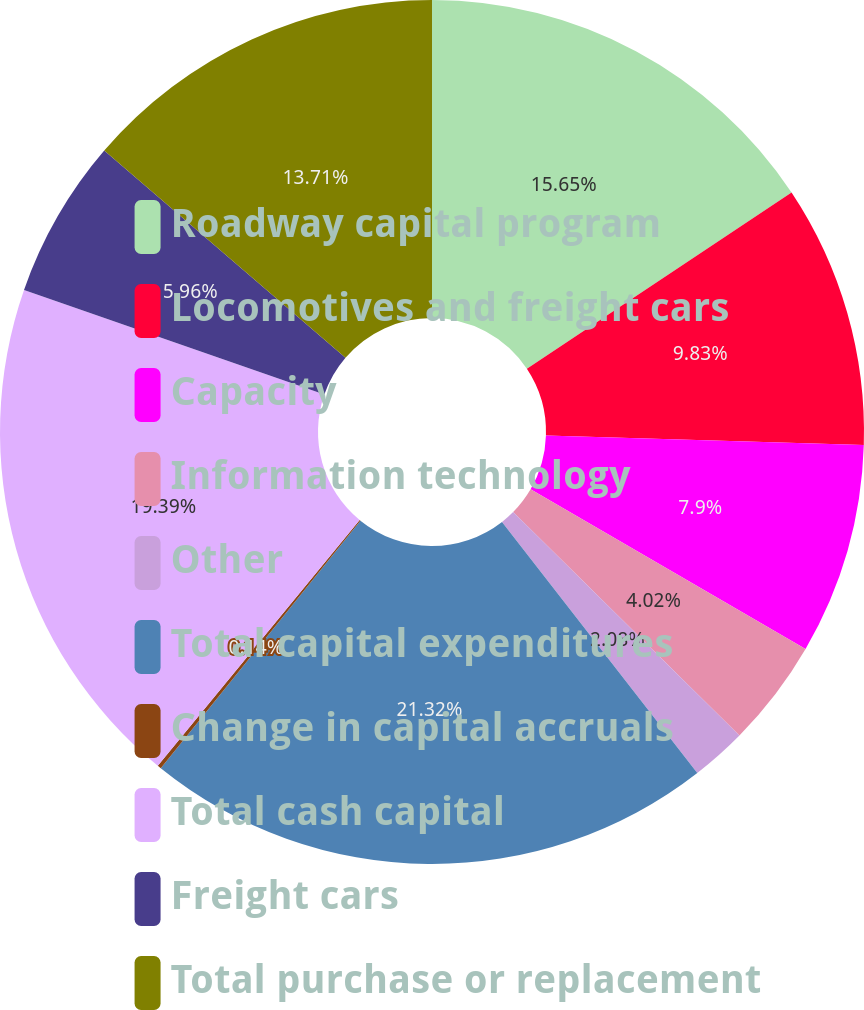Convert chart to OTSL. <chart><loc_0><loc_0><loc_500><loc_500><pie_chart><fcel>Roadway capital program<fcel>Locomotives and freight cars<fcel>Capacity<fcel>Information technology<fcel>Other<fcel>Total capital expenditures<fcel>Change in capital accruals<fcel>Total cash capital<fcel>Freight cars<fcel>Total purchase or replacement<nl><fcel>15.65%<fcel>9.83%<fcel>7.9%<fcel>4.02%<fcel>2.08%<fcel>21.33%<fcel>0.14%<fcel>19.39%<fcel>5.96%<fcel>13.71%<nl></chart> 